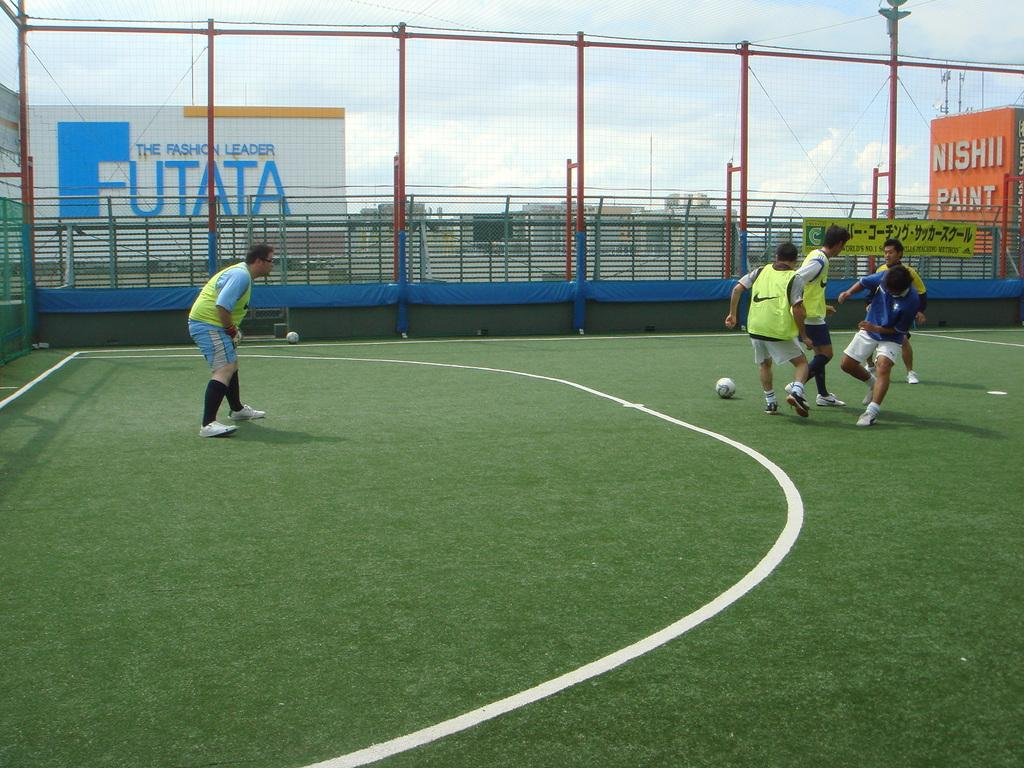<image>
Describe the image concisely. Some people playing soccer on a field with an orange sign about paint behind them. 